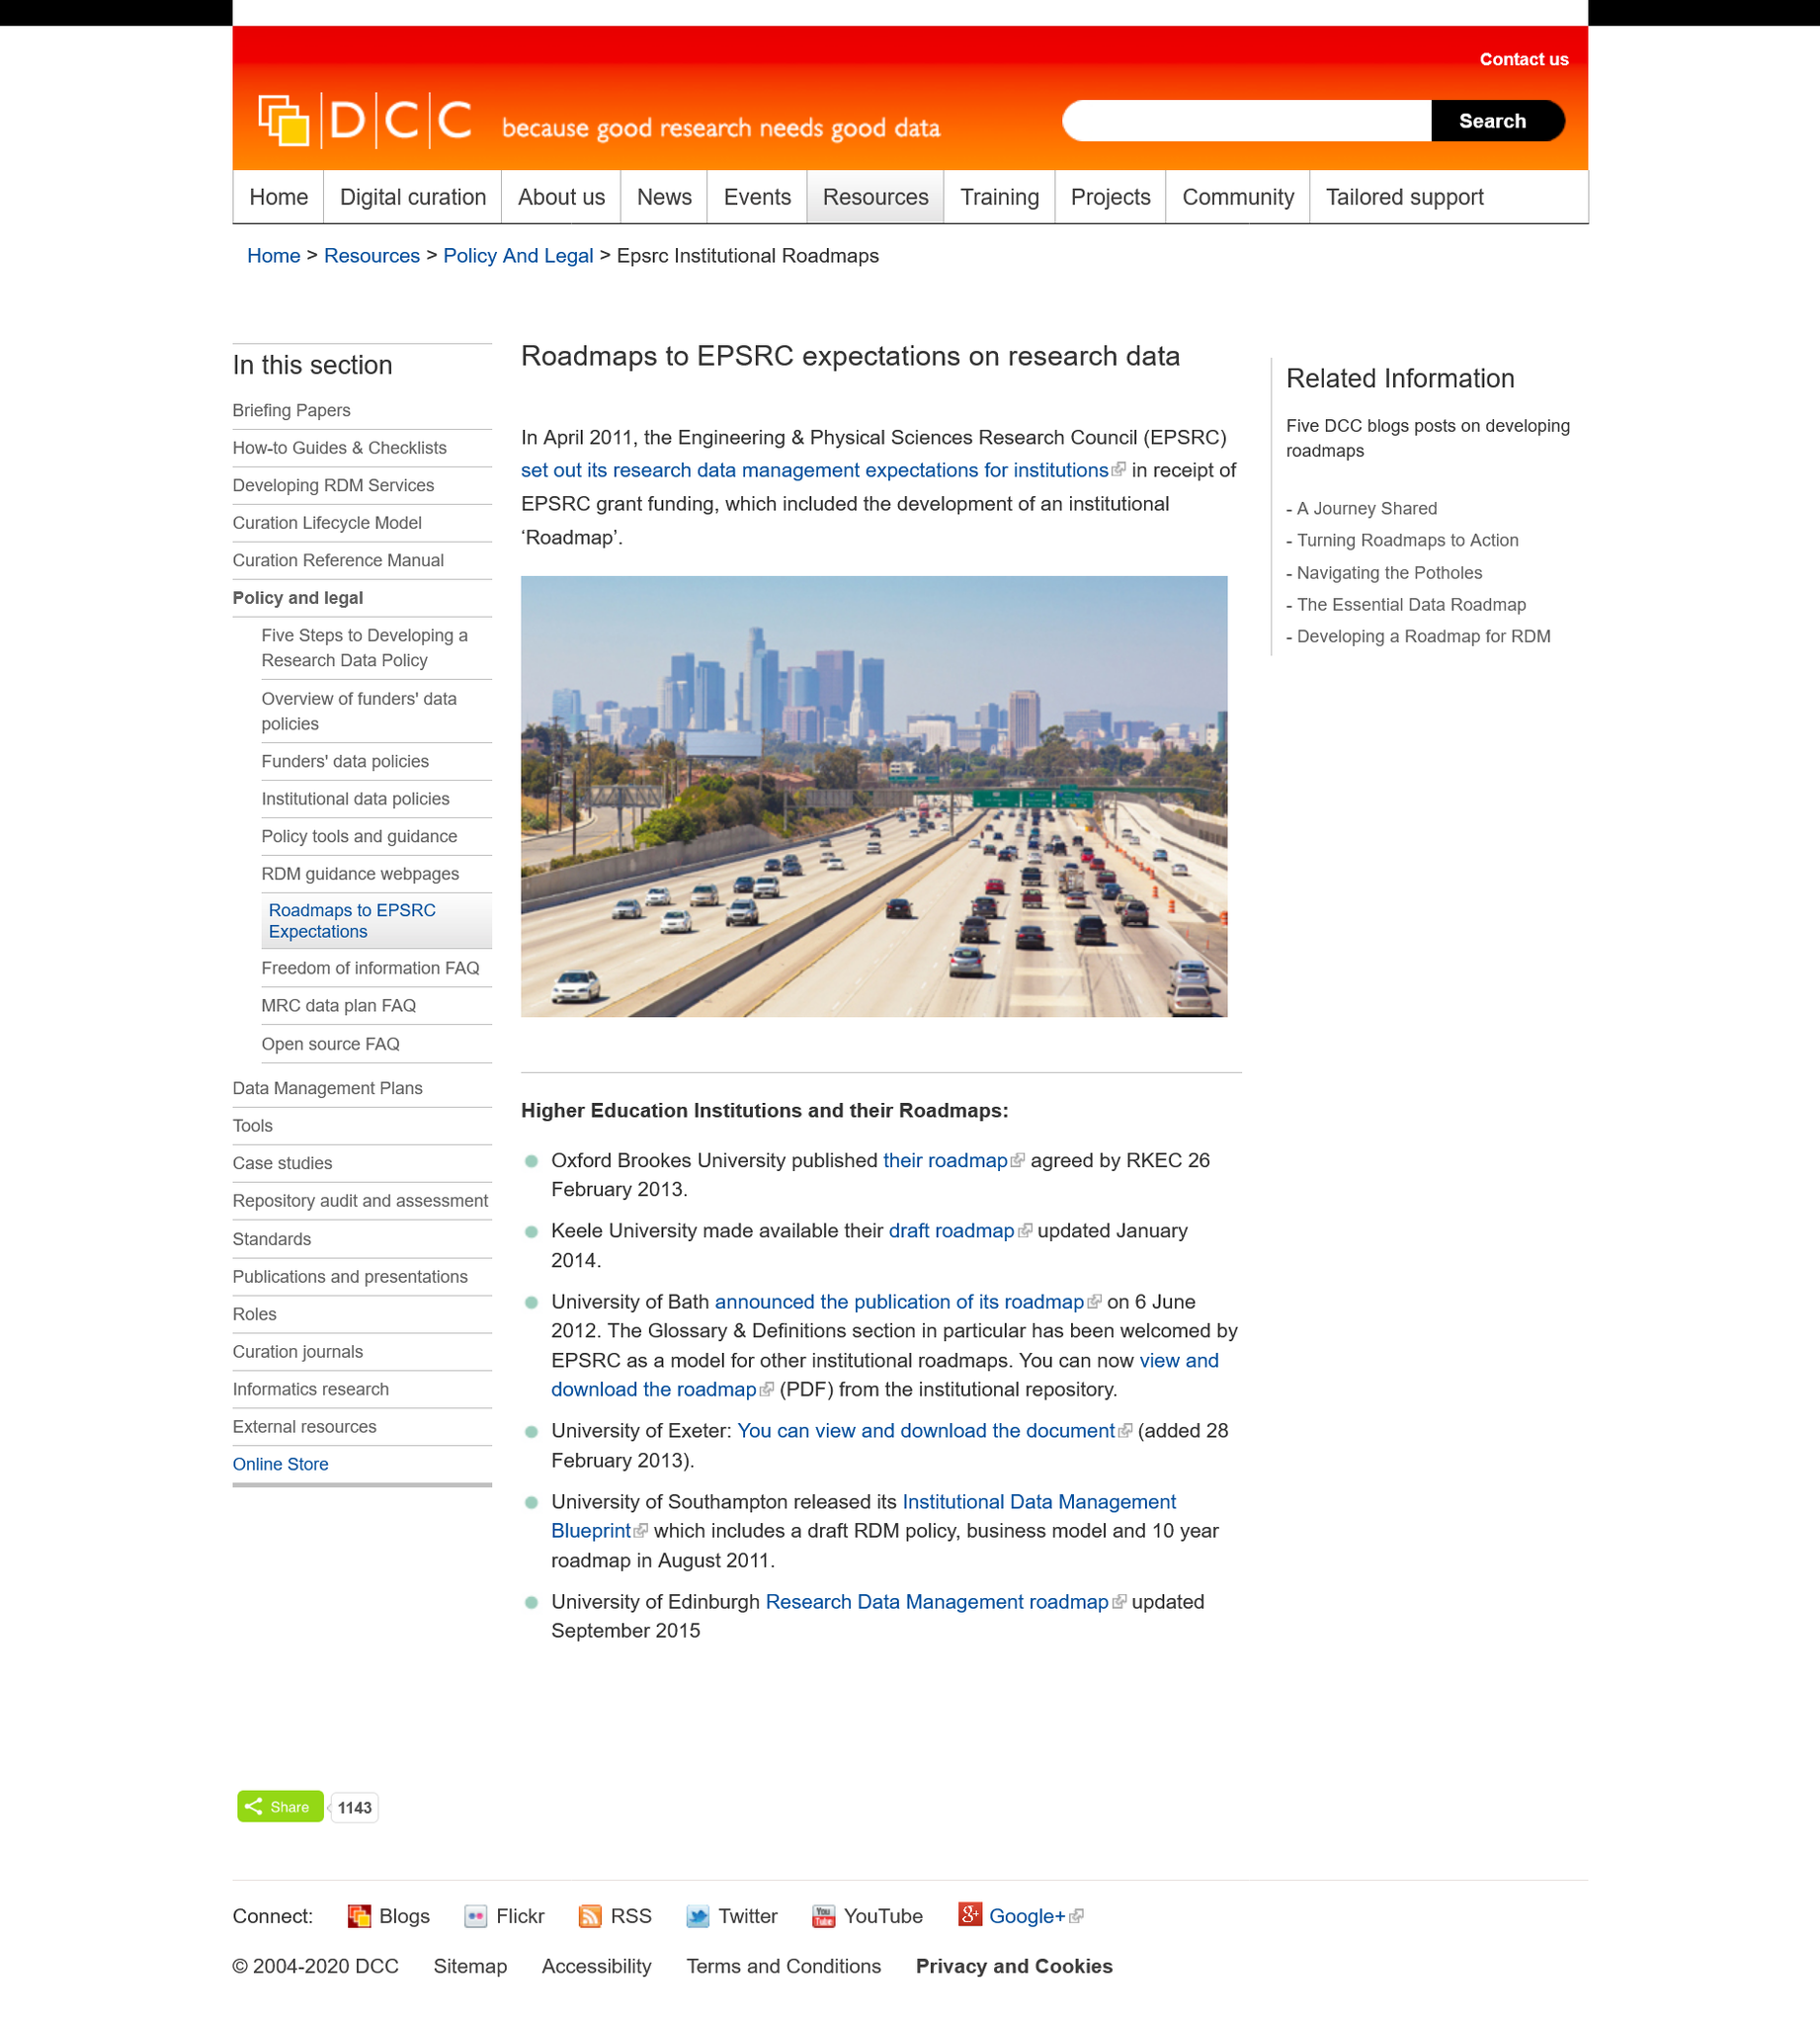Outline some significant characteristics in this image. The Engineering & Physical Sciences Research Council, commonly referred to as EPSRC, is an independent funding agency in the United Kingdom that supports research in the fields of engineering and the physical sciences. The research data management expectations for institutions in receipt of EPSRC grant funding included the development of an institutional 'Roadmap' as part of the research data management requirements. The research data management expectations for institutions were established in April 2011. 